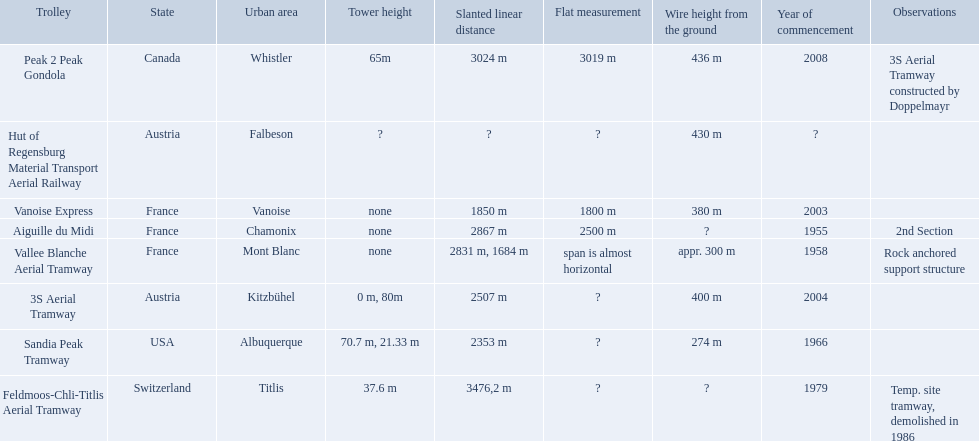Was the sandia peak tramway innagurate before or after the 3s aerial tramway? Before. Write the full table. {'header': ['Trolley', 'State', 'Urban area', 'Tower height', 'Slanted linear distance', 'Flat measurement', 'Wire height from the ground', 'Year of commencement', 'Observations'], 'rows': [['Peak 2 Peak Gondola', 'Canada', 'Whistler', '65m', '3024 m', '3019 m', '436 m', '2008', '3S Aerial Tramway constructed by Doppelmayr'], ['Hut of Regensburg Material Transport Aerial Railway', 'Austria', 'Falbeson', '?', '?', '?', '430 m', '?', ''], ['Vanoise Express', 'France', 'Vanoise', 'none', '1850 m', '1800 m', '380 m', '2003', ''], ['Aiguille du Midi', 'France', 'Chamonix', 'none', '2867 m', '2500 m', '?', '1955', '2nd Section'], ['Vallee Blanche Aerial Tramway', 'France', 'Mont Blanc', 'none', '2831 m, 1684 m', 'span is almost horizontal', 'appr. 300 m', '1958', 'Rock anchored support structure'], ['3S Aerial Tramway', 'Austria', 'Kitzbühel', '0 m, 80m', '2507 m', '?', '400 m', '2004', ''], ['Sandia Peak Tramway', 'USA', 'Albuquerque', '70.7 m, 21.33 m', '2353 m', '?', '274 m', '1966', ''], ['Feldmoos-Chli-Titlis Aerial Tramway', 'Switzerland', 'Titlis', '37.6 m', '3476,2 m', '?', '?', '1979', 'Temp. site tramway, demolished in 1986']]} 